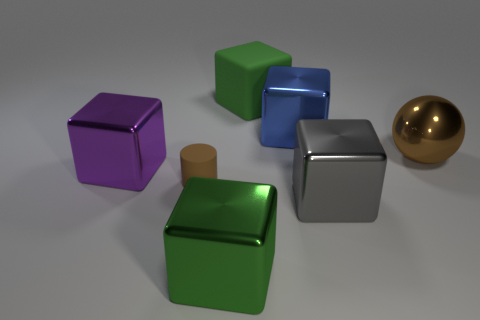The big rubber object is what shape?
Your response must be concise. Cube. There is another matte object that is the same shape as the gray thing; what size is it?
Provide a short and direct response. Large. Is there anything else that is the same material as the large blue cube?
Make the answer very short. Yes. What size is the green block that is behind the purple thing that is behind the big gray metal block?
Your answer should be compact. Large. Are there the same number of big blue blocks in front of the green metallic cube and large brown shiny blocks?
Your response must be concise. Yes. Is the number of matte objects that are left of the green shiny cube less than the number of large things?
Your answer should be compact. Yes. Is there a gray thing of the same size as the cylinder?
Provide a short and direct response. No. There is a tiny matte cylinder; is it the same color as the large metallic cube that is behind the metal sphere?
Give a very brief answer. No. What number of blue metal cubes are in front of the large metal cube on the right side of the blue metallic block?
Make the answer very short. 0. What color is the shiny thing that is to the left of the matte thing that is to the left of the big rubber object?
Provide a short and direct response. Purple. 